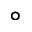<formula> <loc_0><loc_0><loc_500><loc_500>^ { \circ }</formula> 